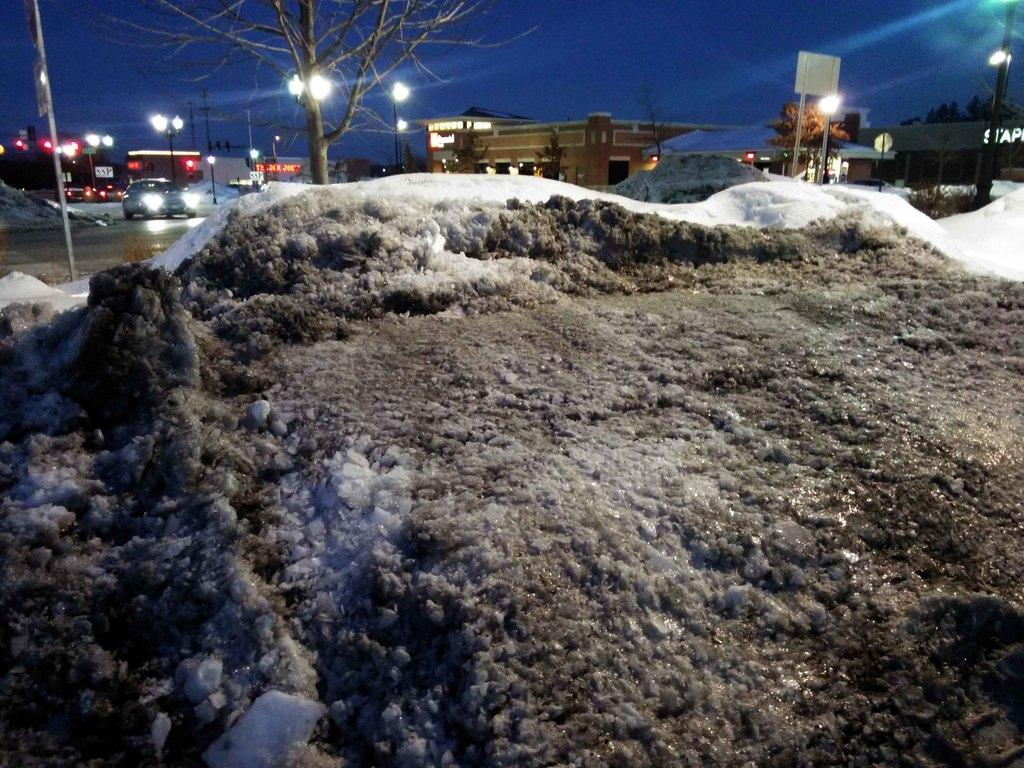What type of weather condition is depicted in the image? There is snow in the image, indicating a wintery or cold weather condition. What can be seen in the background of the image? In the background, there are cars on the road, light poles, trees, houses, and the sky. Can you describe the setting of the image? The image shows a snowy scene with a residential area in the background, including roads, houses, trees, and light poles. Where is the library located in the image? There is no library present in the image; it features a snowy scene with a residential area in the background. Can you tell me how many cats are playing in the snow in the image? There are no cats present in the image; it only shows snow, a residential area, and various background elements. 